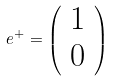<formula> <loc_0><loc_0><loc_500><loc_500>e ^ { + } = \left ( \begin{array} { c } 1 \\ 0 \\ \end{array} \right )</formula> 